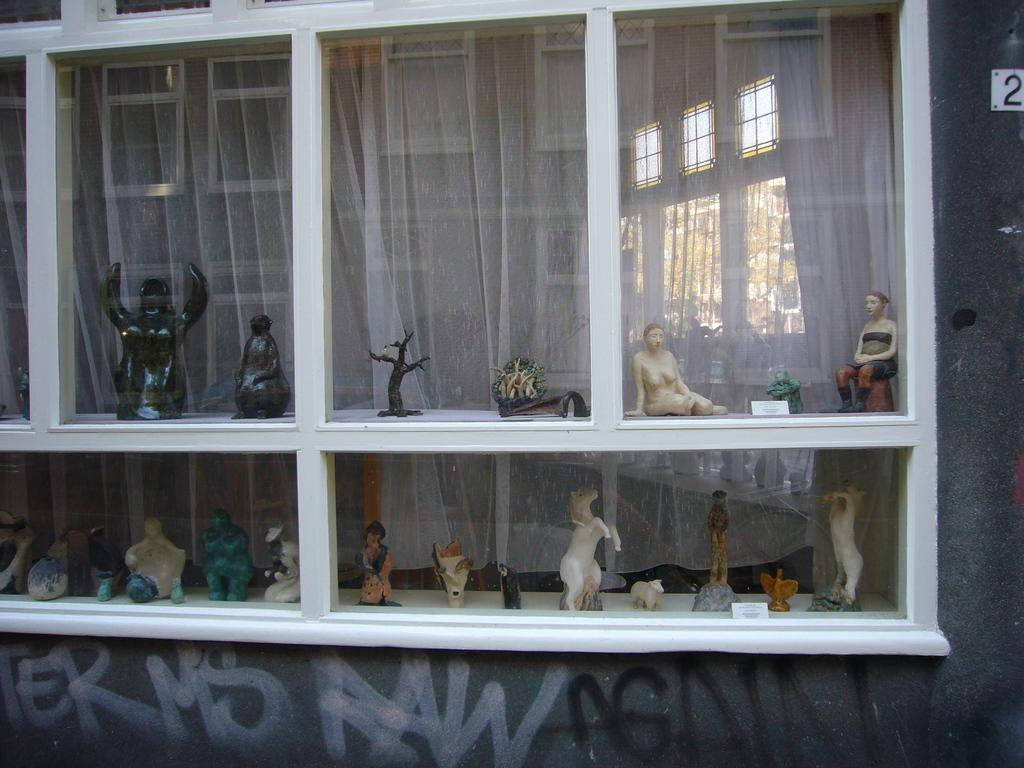What objects are inside the glass cupboard in the image? There are statues in a glass cupboard in the image. What is located behind the glass cupboard? There is a curtain behind the glass cupboard. What can be seen on the wall in the image? There is text visible on the wall. What type of insect can be seen crawling on the text on the wall in the image? There are no insects visible in the image; only statues, a glass cupboard, a curtain, and text on the wall are present. 